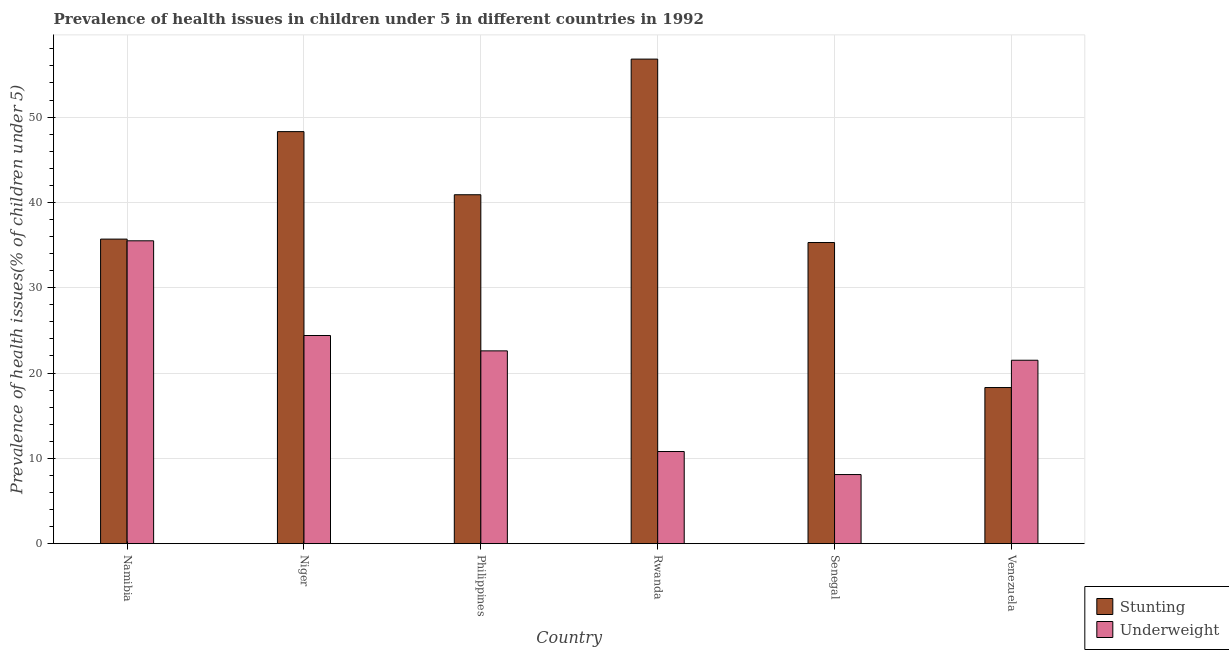How many different coloured bars are there?
Provide a short and direct response. 2. Are the number of bars per tick equal to the number of legend labels?
Give a very brief answer. Yes. Are the number of bars on each tick of the X-axis equal?
Your response must be concise. Yes. How many bars are there on the 1st tick from the left?
Give a very brief answer. 2. How many bars are there on the 5th tick from the right?
Make the answer very short. 2. What is the label of the 5th group of bars from the left?
Your answer should be very brief. Senegal. What is the percentage of stunted children in Philippines?
Offer a very short reply. 40.9. Across all countries, what is the maximum percentage of underweight children?
Your answer should be compact. 35.5. Across all countries, what is the minimum percentage of stunted children?
Keep it short and to the point. 18.3. In which country was the percentage of stunted children maximum?
Provide a short and direct response. Rwanda. In which country was the percentage of stunted children minimum?
Ensure brevity in your answer.  Venezuela. What is the total percentage of underweight children in the graph?
Offer a terse response. 122.9. What is the difference between the percentage of stunted children in Namibia and that in Niger?
Your answer should be compact. -12.6. What is the difference between the percentage of stunted children in Rwanda and the percentage of underweight children in Namibia?
Ensure brevity in your answer.  21.3. What is the average percentage of stunted children per country?
Provide a succinct answer. 39.22. What is the difference between the percentage of underweight children and percentage of stunted children in Senegal?
Ensure brevity in your answer.  -27.2. What is the ratio of the percentage of stunted children in Namibia to that in Philippines?
Offer a very short reply. 0.87. Is the percentage of underweight children in Namibia less than that in Senegal?
Ensure brevity in your answer.  No. What is the difference between the highest and the second highest percentage of stunted children?
Give a very brief answer. 8.5. What is the difference between the highest and the lowest percentage of underweight children?
Make the answer very short. 27.4. In how many countries, is the percentage of underweight children greater than the average percentage of underweight children taken over all countries?
Your answer should be very brief. 4. What does the 2nd bar from the left in Rwanda represents?
Make the answer very short. Underweight. What does the 1st bar from the right in Senegal represents?
Your answer should be compact. Underweight. Are all the bars in the graph horizontal?
Your answer should be very brief. No. How many countries are there in the graph?
Provide a short and direct response. 6. What is the difference between two consecutive major ticks on the Y-axis?
Make the answer very short. 10. How are the legend labels stacked?
Keep it short and to the point. Vertical. What is the title of the graph?
Offer a very short reply. Prevalence of health issues in children under 5 in different countries in 1992. What is the label or title of the X-axis?
Offer a very short reply. Country. What is the label or title of the Y-axis?
Your answer should be very brief. Prevalence of health issues(% of children under 5). What is the Prevalence of health issues(% of children under 5) of Stunting in Namibia?
Provide a short and direct response. 35.7. What is the Prevalence of health issues(% of children under 5) in Underweight in Namibia?
Offer a terse response. 35.5. What is the Prevalence of health issues(% of children under 5) in Stunting in Niger?
Ensure brevity in your answer.  48.3. What is the Prevalence of health issues(% of children under 5) of Underweight in Niger?
Offer a very short reply. 24.4. What is the Prevalence of health issues(% of children under 5) in Stunting in Philippines?
Provide a short and direct response. 40.9. What is the Prevalence of health issues(% of children under 5) in Underweight in Philippines?
Your response must be concise. 22.6. What is the Prevalence of health issues(% of children under 5) in Stunting in Rwanda?
Provide a succinct answer. 56.8. What is the Prevalence of health issues(% of children under 5) in Underweight in Rwanda?
Your answer should be very brief. 10.8. What is the Prevalence of health issues(% of children under 5) in Stunting in Senegal?
Your answer should be very brief. 35.3. What is the Prevalence of health issues(% of children under 5) in Underweight in Senegal?
Offer a very short reply. 8.1. What is the Prevalence of health issues(% of children under 5) in Stunting in Venezuela?
Give a very brief answer. 18.3. What is the Prevalence of health issues(% of children under 5) of Underweight in Venezuela?
Your answer should be very brief. 21.5. Across all countries, what is the maximum Prevalence of health issues(% of children under 5) in Stunting?
Offer a very short reply. 56.8. Across all countries, what is the maximum Prevalence of health issues(% of children under 5) of Underweight?
Ensure brevity in your answer.  35.5. Across all countries, what is the minimum Prevalence of health issues(% of children under 5) in Stunting?
Make the answer very short. 18.3. Across all countries, what is the minimum Prevalence of health issues(% of children under 5) of Underweight?
Make the answer very short. 8.1. What is the total Prevalence of health issues(% of children under 5) in Stunting in the graph?
Provide a succinct answer. 235.3. What is the total Prevalence of health issues(% of children under 5) of Underweight in the graph?
Provide a short and direct response. 122.9. What is the difference between the Prevalence of health issues(% of children under 5) in Stunting in Namibia and that in Niger?
Provide a succinct answer. -12.6. What is the difference between the Prevalence of health issues(% of children under 5) in Stunting in Namibia and that in Philippines?
Provide a short and direct response. -5.2. What is the difference between the Prevalence of health issues(% of children under 5) of Underweight in Namibia and that in Philippines?
Your answer should be very brief. 12.9. What is the difference between the Prevalence of health issues(% of children under 5) of Stunting in Namibia and that in Rwanda?
Make the answer very short. -21.1. What is the difference between the Prevalence of health issues(% of children under 5) of Underweight in Namibia and that in Rwanda?
Keep it short and to the point. 24.7. What is the difference between the Prevalence of health issues(% of children under 5) in Stunting in Namibia and that in Senegal?
Offer a terse response. 0.4. What is the difference between the Prevalence of health issues(% of children under 5) of Underweight in Namibia and that in Senegal?
Keep it short and to the point. 27.4. What is the difference between the Prevalence of health issues(% of children under 5) in Stunting in Namibia and that in Venezuela?
Make the answer very short. 17.4. What is the difference between the Prevalence of health issues(% of children under 5) of Stunting in Niger and that in Philippines?
Your answer should be very brief. 7.4. What is the difference between the Prevalence of health issues(% of children under 5) in Underweight in Niger and that in Rwanda?
Your answer should be compact. 13.6. What is the difference between the Prevalence of health issues(% of children under 5) in Stunting in Niger and that in Senegal?
Provide a succinct answer. 13. What is the difference between the Prevalence of health issues(% of children under 5) of Underweight in Niger and that in Senegal?
Make the answer very short. 16.3. What is the difference between the Prevalence of health issues(% of children under 5) of Stunting in Philippines and that in Rwanda?
Provide a succinct answer. -15.9. What is the difference between the Prevalence of health issues(% of children under 5) of Stunting in Philippines and that in Senegal?
Your answer should be very brief. 5.6. What is the difference between the Prevalence of health issues(% of children under 5) in Stunting in Philippines and that in Venezuela?
Offer a very short reply. 22.6. What is the difference between the Prevalence of health issues(% of children under 5) of Stunting in Rwanda and that in Senegal?
Keep it short and to the point. 21.5. What is the difference between the Prevalence of health issues(% of children under 5) in Underweight in Rwanda and that in Senegal?
Offer a very short reply. 2.7. What is the difference between the Prevalence of health issues(% of children under 5) of Stunting in Rwanda and that in Venezuela?
Provide a succinct answer. 38.5. What is the difference between the Prevalence of health issues(% of children under 5) of Underweight in Rwanda and that in Venezuela?
Offer a terse response. -10.7. What is the difference between the Prevalence of health issues(% of children under 5) in Stunting in Namibia and the Prevalence of health issues(% of children under 5) in Underweight in Niger?
Keep it short and to the point. 11.3. What is the difference between the Prevalence of health issues(% of children under 5) of Stunting in Namibia and the Prevalence of health issues(% of children under 5) of Underweight in Rwanda?
Offer a very short reply. 24.9. What is the difference between the Prevalence of health issues(% of children under 5) of Stunting in Namibia and the Prevalence of health issues(% of children under 5) of Underweight in Senegal?
Offer a very short reply. 27.6. What is the difference between the Prevalence of health issues(% of children under 5) of Stunting in Namibia and the Prevalence of health issues(% of children under 5) of Underweight in Venezuela?
Your answer should be very brief. 14.2. What is the difference between the Prevalence of health issues(% of children under 5) of Stunting in Niger and the Prevalence of health issues(% of children under 5) of Underweight in Philippines?
Provide a short and direct response. 25.7. What is the difference between the Prevalence of health issues(% of children under 5) of Stunting in Niger and the Prevalence of health issues(% of children under 5) of Underweight in Rwanda?
Offer a terse response. 37.5. What is the difference between the Prevalence of health issues(% of children under 5) in Stunting in Niger and the Prevalence of health issues(% of children under 5) in Underweight in Senegal?
Give a very brief answer. 40.2. What is the difference between the Prevalence of health issues(% of children under 5) in Stunting in Niger and the Prevalence of health issues(% of children under 5) in Underweight in Venezuela?
Offer a terse response. 26.8. What is the difference between the Prevalence of health issues(% of children under 5) of Stunting in Philippines and the Prevalence of health issues(% of children under 5) of Underweight in Rwanda?
Your answer should be compact. 30.1. What is the difference between the Prevalence of health issues(% of children under 5) of Stunting in Philippines and the Prevalence of health issues(% of children under 5) of Underweight in Senegal?
Give a very brief answer. 32.8. What is the difference between the Prevalence of health issues(% of children under 5) in Stunting in Philippines and the Prevalence of health issues(% of children under 5) in Underweight in Venezuela?
Provide a succinct answer. 19.4. What is the difference between the Prevalence of health issues(% of children under 5) of Stunting in Rwanda and the Prevalence of health issues(% of children under 5) of Underweight in Senegal?
Offer a terse response. 48.7. What is the difference between the Prevalence of health issues(% of children under 5) of Stunting in Rwanda and the Prevalence of health issues(% of children under 5) of Underweight in Venezuela?
Make the answer very short. 35.3. What is the difference between the Prevalence of health issues(% of children under 5) in Stunting in Senegal and the Prevalence of health issues(% of children under 5) in Underweight in Venezuela?
Your answer should be compact. 13.8. What is the average Prevalence of health issues(% of children under 5) of Stunting per country?
Your answer should be compact. 39.22. What is the average Prevalence of health issues(% of children under 5) of Underweight per country?
Provide a succinct answer. 20.48. What is the difference between the Prevalence of health issues(% of children under 5) of Stunting and Prevalence of health issues(% of children under 5) of Underweight in Namibia?
Offer a very short reply. 0.2. What is the difference between the Prevalence of health issues(% of children under 5) of Stunting and Prevalence of health issues(% of children under 5) of Underweight in Niger?
Your answer should be very brief. 23.9. What is the difference between the Prevalence of health issues(% of children under 5) in Stunting and Prevalence of health issues(% of children under 5) in Underweight in Senegal?
Your response must be concise. 27.2. What is the ratio of the Prevalence of health issues(% of children under 5) in Stunting in Namibia to that in Niger?
Offer a very short reply. 0.74. What is the ratio of the Prevalence of health issues(% of children under 5) of Underweight in Namibia to that in Niger?
Make the answer very short. 1.45. What is the ratio of the Prevalence of health issues(% of children under 5) of Stunting in Namibia to that in Philippines?
Offer a very short reply. 0.87. What is the ratio of the Prevalence of health issues(% of children under 5) in Underweight in Namibia to that in Philippines?
Your answer should be very brief. 1.57. What is the ratio of the Prevalence of health issues(% of children under 5) of Stunting in Namibia to that in Rwanda?
Ensure brevity in your answer.  0.63. What is the ratio of the Prevalence of health issues(% of children under 5) in Underweight in Namibia to that in Rwanda?
Offer a very short reply. 3.29. What is the ratio of the Prevalence of health issues(% of children under 5) of Stunting in Namibia to that in Senegal?
Keep it short and to the point. 1.01. What is the ratio of the Prevalence of health issues(% of children under 5) in Underweight in Namibia to that in Senegal?
Keep it short and to the point. 4.38. What is the ratio of the Prevalence of health issues(% of children under 5) in Stunting in Namibia to that in Venezuela?
Keep it short and to the point. 1.95. What is the ratio of the Prevalence of health issues(% of children under 5) in Underweight in Namibia to that in Venezuela?
Make the answer very short. 1.65. What is the ratio of the Prevalence of health issues(% of children under 5) in Stunting in Niger to that in Philippines?
Ensure brevity in your answer.  1.18. What is the ratio of the Prevalence of health issues(% of children under 5) in Underweight in Niger to that in Philippines?
Your response must be concise. 1.08. What is the ratio of the Prevalence of health issues(% of children under 5) of Stunting in Niger to that in Rwanda?
Your response must be concise. 0.85. What is the ratio of the Prevalence of health issues(% of children under 5) in Underweight in Niger to that in Rwanda?
Keep it short and to the point. 2.26. What is the ratio of the Prevalence of health issues(% of children under 5) of Stunting in Niger to that in Senegal?
Keep it short and to the point. 1.37. What is the ratio of the Prevalence of health issues(% of children under 5) in Underweight in Niger to that in Senegal?
Your response must be concise. 3.01. What is the ratio of the Prevalence of health issues(% of children under 5) of Stunting in Niger to that in Venezuela?
Ensure brevity in your answer.  2.64. What is the ratio of the Prevalence of health issues(% of children under 5) in Underweight in Niger to that in Venezuela?
Your response must be concise. 1.13. What is the ratio of the Prevalence of health issues(% of children under 5) of Stunting in Philippines to that in Rwanda?
Keep it short and to the point. 0.72. What is the ratio of the Prevalence of health issues(% of children under 5) in Underweight in Philippines to that in Rwanda?
Make the answer very short. 2.09. What is the ratio of the Prevalence of health issues(% of children under 5) in Stunting in Philippines to that in Senegal?
Your answer should be very brief. 1.16. What is the ratio of the Prevalence of health issues(% of children under 5) in Underweight in Philippines to that in Senegal?
Give a very brief answer. 2.79. What is the ratio of the Prevalence of health issues(% of children under 5) in Stunting in Philippines to that in Venezuela?
Provide a short and direct response. 2.23. What is the ratio of the Prevalence of health issues(% of children under 5) of Underweight in Philippines to that in Venezuela?
Give a very brief answer. 1.05. What is the ratio of the Prevalence of health issues(% of children under 5) in Stunting in Rwanda to that in Senegal?
Provide a succinct answer. 1.61. What is the ratio of the Prevalence of health issues(% of children under 5) in Underweight in Rwanda to that in Senegal?
Keep it short and to the point. 1.33. What is the ratio of the Prevalence of health issues(% of children under 5) of Stunting in Rwanda to that in Venezuela?
Your response must be concise. 3.1. What is the ratio of the Prevalence of health issues(% of children under 5) of Underweight in Rwanda to that in Venezuela?
Keep it short and to the point. 0.5. What is the ratio of the Prevalence of health issues(% of children under 5) of Stunting in Senegal to that in Venezuela?
Your response must be concise. 1.93. What is the ratio of the Prevalence of health issues(% of children under 5) in Underweight in Senegal to that in Venezuela?
Make the answer very short. 0.38. What is the difference between the highest and the second highest Prevalence of health issues(% of children under 5) in Stunting?
Provide a short and direct response. 8.5. What is the difference between the highest and the lowest Prevalence of health issues(% of children under 5) of Stunting?
Give a very brief answer. 38.5. What is the difference between the highest and the lowest Prevalence of health issues(% of children under 5) in Underweight?
Make the answer very short. 27.4. 